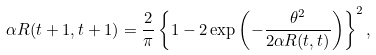Convert formula to latex. <formula><loc_0><loc_0><loc_500><loc_500>\alpha R ( t + 1 , t + 1 ) = \frac { 2 } { \pi } \left \{ 1 - 2 \exp \left ( - \frac { \theta ^ { 2 } } { 2 \alpha R ( t , t ) } \right ) \right \} ^ { 2 } ,</formula> 